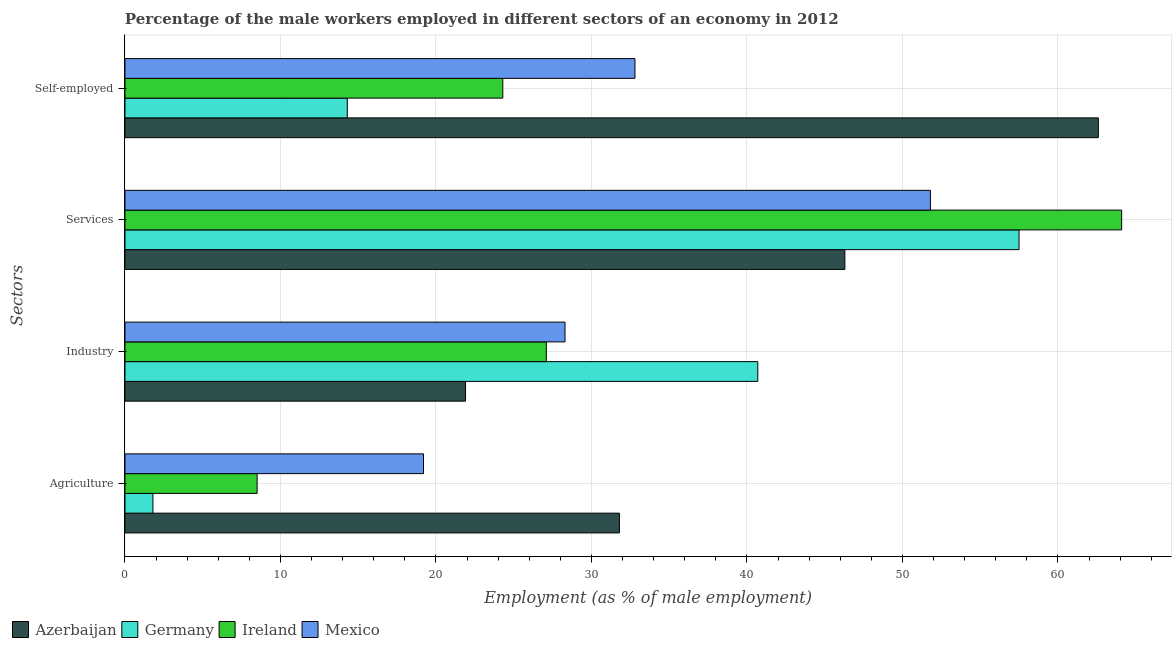How many different coloured bars are there?
Offer a very short reply. 4. How many groups of bars are there?
Give a very brief answer. 4. Are the number of bars on each tick of the Y-axis equal?
Ensure brevity in your answer.  Yes. What is the label of the 4th group of bars from the top?
Your answer should be compact. Agriculture. What is the percentage of male workers in agriculture in Ireland?
Offer a very short reply. 8.5. Across all countries, what is the maximum percentage of self employed male workers?
Provide a short and direct response. 62.6. Across all countries, what is the minimum percentage of male workers in agriculture?
Your response must be concise. 1.8. In which country was the percentage of male workers in industry maximum?
Offer a very short reply. Germany. In which country was the percentage of self employed male workers minimum?
Your response must be concise. Germany. What is the total percentage of male workers in industry in the graph?
Ensure brevity in your answer.  118. What is the difference between the percentage of male workers in agriculture in Ireland and that in Germany?
Your answer should be compact. 6.7. What is the difference between the percentage of male workers in agriculture in Mexico and the percentage of self employed male workers in Ireland?
Keep it short and to the point. -5.1. What is the average percentage of male workers in agriculture per country?
Provide a succinct answer. 15.32. What is the difference between the percentage of male workers in industry and percentage of male workers in services in Ireland?
Offer a very short reply. -37. What is the ratio of the percentage of male workers in agriculture in Mexico to that in Ireland?
Your response must be concise. 2.26. Is the percentage of male workers in services in Ireland less than that in Mexico?
Keep it short and to the point. No. What is the difference between the highest and the second highest percentage of male workers in agriculture?
Give a very brief answer. 12.6. What is the difference between the highest and the lowest percentage of male workers in industry?
Offer a terse response. 18.8. Is the sum of the percentage of male workers in agriculture in Mexico and Germany greater than the maximum percentage of male workers in industry across all countries?
Provide a succinct answer. No. What does the 1st bar from the top in Self-employed represents?
Make the answer very short. Mexico. What does the 2nd bar from the bottom in Industry represents?
Make the answer very short. Germany. What is the difference between two consecutive major ticks on the X-axis?
Offer a terse response. 10. Does the graph contain grids?
Give a very brief answer. Yes. How many legend labels are there?
Your answer should be compact. 4. How are the legend labels stacked?
Give a very brief answer. Horizontal. What is the title of the graph?
Your response must be concise. Percentage of the male workers employed in different sectors of an economy in 2012. What is the label or title of the X-axis?
Offer a terse response. Employment (as % of male employment). What is the label or title of the Y-axis?
Provide a succinct answer. Sectors. What is the Employment (as % of male employment) in Azerbaijan in Agriculture?
Ensure brevity in your answer.  31.8. What is the Employment (as % of male employment) of Germany in Agriculture?
Offer a terse response. 1.8. What is the Employment (as % of male employment) in Ireland in Agriculture?
Your response must be concise. 8.5. What is the Employment (as % of male employment) in Mexico in Agriculture?
Keep it short and to the point. 19.2. What is the Employment (as % of male employment) in Azerbaijan in Industry?
Offer a very short reply. 21.9. What is the Employment (as % of male employment) of Germany in Industry?
Ensure brevity in your answer.  40.7. What is the Employment (as % of male employment) of Ireland in Industry?
Offer a terse response. 27.1. What is the Employment (as % of male employment) in Mexico in Industry?
Your answer should be compact. 28.3. What is the Employment (as % of male employment) in Azerbaijan in Services?
Give a very brief answer. 46.3. What is the Employment (as % of male employment) in Germany in Services?
Provide a short and direct response. 57.5. What is the Employment (as % of male employment) in Ireland in Services?
Offer a very short reply. 64.1. What is the Employment (as % of male employment) in Mexico in Services?
Your response must be concise. 51.8. What is the Employment (as % of male employment) of Azerbaijan in Self-employed?
Make the answer very short. 62.6. What is the Employment (as % of male employment) in Germany in Self-employed?
Your answer should be very brief. 14.3. What is the Employment (as % of male employment) in Ireland in Self-employed?
Keep it short and to the point. 24.3. What is the Employment (as % of male employment) in Mexico in Self-employed?
Make the answer very short. 32.8. Across all Sectors, what is the maximum Employment (as % of male employment) of Azerbaijan?
Keep it short and to the point. 62.6. Across all Sectors, what is the maximum Employment (as % of male employment) in Germany?
Offer a terse response. 57.5. Across all Sectors, what is the maximum Employment (as % of male employment) of Ireland?
Keep it short and to the point. 64.1. Across all Sectors, what is the maximum Employment (as % of male employment) in Mexico?
Your response must be concise. 51.8. Across all Sectors, what is the minimum Employment (as % of male employment) in Azerbaijan?
Your answer should be very brief. 21.9. Across all Sectors, what is the minimum Employment (as % of male employment) of Germany?
Ensure brevity in your answer.  1.8. Across all Sectors, what is the minimum Employment (as % of male employment) of Mexico?
Offer a very short reply. 19.2. What is the total Employment (as % of male employment) of Azerbaijan in the graph?
Provide a short and direct response. 162.6. What is the total Employment (as % of male employment) of Germany in the graph?
Ensure brevity in your answer.  114.3. What is the total Employment (as % of male employment) in Ireland in the graph?
Your answer should be compact. 124. What is the total Employment (as % of male employment) of Mexico in the graph?
Ensure brevity in your answer.  132.1. What is the difference between the Employment (as % of male employment) in Germany in Agriculture and that in Industry?
Provide a short and direct response. -38.9. What is the difference between the Employment (as % of male employment) in Ireland in Agriculture and that in Industry?
Keep it short and to the point. -18.6. What is the difference between the Employment (as % of male employment) in Mexico in Agriculture and that in Industry?
Provide a succinct answer. -9.1. What is the difference between the Employment (as % of male employment) in Azerbaijan in Agriculture and that in Services?
Give a very brief answer. -14.5. What is the difference between the Employment (as % of male employment) in Germany in Agriculture and that in Services?
Make the answer very short. -55.7. What is the difference between the Employment (as % of male employment) of Ireland in Agriculture and that in Services?
Offer a terse response. -55.6. What is the difference between the Employment (as % of male employment) in Mexico in Agriculture and that in Services?
Offer a very short reply. -32.6. What is the difference between the Employment (as % of male employment) in Azerbaijan in Agriculture and that in Self-employed?
Provide a succinct answer. -30.8. What is the difference between the Employment (as % of male employment) of Ireland in Agriculture and that in Self-employed?
Ensure brevity in your answer.  -15.8. What is the difference between the Employment (as % of male employment) of Azerbaijan in Industry and that in Services?
Your answer should be very brief. -24.4. What is the difference between the Employment (as % of male employment) in Germany in Industry and that in Services?
Your answer should be compact. -16.8. What is the difference between the Employment (as % of male employment) in Ireland in Industry and that in Services?
Provide a succinct answer. -37. What is the difference between the Employment (as % of male employment) in Mexico in Industry and that in Services?
Your answer should be compact. -23.5. What is the difference between the Employment (as % of male employment) in Azerbaijan in Industry and that in Self-employed?
Your answer should be compact. -40.7. What is the difference between the Employment (as % of male employment) in Germany in Industry and that in Self-employed?
Keep it short and to the point. 26.4. What is the difference between the Employment (as % of male employment) of Mexico in Industry and that in Self-employed?
Offer a terse response. -4.5. What is the difference between the Employment (as % of male employment) in Azerbaijan in Services and that in Self-employed?
Make the answer very short. -16.3. What is the difference between the Employment (as % of male employment) of Germany in Services and that in Self-employed?
Keep it short and to the point. 43.2. What is the difference between the Employment (as % of male employment) of Ireland in Services and that in Self-employed?
Give a very brief answer. 39.8. What is the difference between the Employment (as % of male employment) in Mexico in Services and that in Self-employed?
Make the answer very short. 19. What is the difference between the Employment (as % of male employment) of Azerbaijan in Agriculture and the Employment (as % of male employment) of Germany in Industry?
Give a very brief answer. -8.9. What is the difference between the Employment (as % of male employment) of Azerbaijan in Agriculture and the Employment (as % of male employment) of Ireland in Industry?
Your answer should be compact. 4.7. What is the difference between the Employment (as % of male employment) in Azerbaijan in Agriculture and the Employment (as % of male employment) in Mexico in Industry?
Offer a very short reply. 3.5. What is the difference between the Employment (as % of male employment) in Germany in Agriculture and the Employment (as % of male employment) in Ireland in Industry?
Ensure brevity in your answer.  -25.3. What is the difference between the Employment (as % of male employment) of Germany in Agriculture and the Employment (as % of male employment) of Mexico in Industry?
Offer a terse response. -26.5. What is the difference between the Employment (as % of male employment) of Ireland in Agriculture and the Employment (as % of male employment) of Mexico in Industry?
Offer a terse response. -19.8. What is the difference between the Employment (as % of male employment) in Azerbaijan in Agriculture and the Employment (as % of male employment) in Germany in Services?
Provide a short and direct response. -25.7. What is the difference between the Employment (as % of male employment) of Azerbaijan in Agriculture and the Employment (as % of male employment) of Ireland in Services?
Provide a short and direct response. -32.3. What is the difference between the Employment (as % of male employment) in Azerbaijan in Agriculture and the Employment (as % of male employment) in Mexico in Services?
Provide a succinct answer. -20. What is the difference between the Employment (as % of male employment) in Germany in Agriculture and the Employment (as % of male employment) in Ireland in Services?
Offer a terse response. -62.3. What is the difference between the Employment (as % of male employment) in Germany in Agriculture and the Employment (as % of male employment) in Mexico in Services?
Your answer should be compact. -50. What is the difference between the Employment (as % of male employment) in Ireland in Agriculture and the Employment (as % of male employment) in Mexico in Services?
Your response must be concise. -43.3. What is the difference between the Employment (as % of male employment) in Azerbaijan in Agriculture and the Employment (as % of male employment) in Germany in Self-employed?
Your response must be concise. 17.5. What is the difference between the Employment (as % of male employment) of Azerbaijan in Agriculture and the Employment (as % of male employment) of Ireland in Self-employed?
Your response must be concise. 7.5. What is the difference between the Employment (as % of male employment) in Germany in Agriculture and the Employment (as % of male employment) in Ireland in Self-employed?
Provide a short and direct response. -22.5. What is the difference between the Employment (as % of male employment) of Germany in Agriculture and the Employment (as % of male employment) of Mexico in Self-employed?
Your answer should be compact. -31. What is the difference between the Employment (as % of male employment) of Ireland in Agriculture and the Employment (as % of male employment) of Mexico in Self-employed?
Make the answer very short. -24.3. What is the difference between the Employment (as % of male employment) in Azerbaijan in Industry and the Employment (as % of male employment) in Germany in Services?
Your answer should be very brief. -35.6. What is the difference between the Employment (as % of male employment) of Azerbaijan in Industry and the Employment (as % of male employment) of Ireland in Services?
Ensure brevity in your answer.  -42.2. What is the difference between the Employment (as % of male employment) in Azerbaijan in Industry and the Employment (as % of male employment) in Mexico in Services?
Offer a terse response. -29.9. What is the difference between the Employment (as % of male employment) in Germany in Industry and the Employment (as % of male employment) in Ireland in Services?
Your answer should be very brief. -23.4. What is the difference between the Employment (as % of male employment) of Ireland in Industry and the Employment (as % of male employment) of Mexico in Services?
Your response must be concise. -24.7. What is the difference between the Employment (as % of male employment) of Azerbaijan in Industry and the Employment (as % of male employment) of Mexico in Self-employed?
Your response must be concise. -10.9. What is the difference between the Employment (as % of male employment) in Germany in Industry and the Employment (as % of male employment) in Ireland in Self-employed?
Your response must be concise. 16.4. What is the difference between the Employment (as % of male employment) in Ireland in Industry and the Employment (as % of male employment) in Mexico in Self-employed?
Ensure brevity in your answer.  -5.7. What is the difference between the Employment (as % of male employment) of Azerbaijan in Services and the Employment (as % of male employment) of Ireland in Self-employed?
Provide a short and direct response. 22. What is the difference between the Employment (as % of male employment) in Germany in Services and the Employment (as % of male employment) in Ireland in Self-employed?
Give a very brief answer. 33.2. What is the difference between the Employment (as % of male employment) of Germany in Services and the Employment (as % of male employment) of Mexico in Self-employed?
Make the answer very short. 24.7. What is the difference between the Employment (as % of male employment) in Ireland in Services and the Employment (as % of male employment) in Mexico in Self-employed?
Provide a succinct answer. 31.3. What is the average Employment (as % of male employment) of Azerbaijan per Sectors?
Your response must be concise. 40.65. What is the average Employment (as % of male employment) in Germany per Sectors?
Give a very brief answer. 28.57. What is the average Employment (as % of male employment) of Mexico per Sectors?
Make the answer very short. 33.02. What is the difference between the Employment (as % of male employment) of Azerbaijan and Employment (as % of male employment) of Germany in Agriculture?
Ensure brevity in your answer.  30. What is the difference between the Employment (as % of male employment) of Azerbaijan and Employment (as % of male employment) of Ireland in Agriculture?
Offer a very short reply. 23.3. What is the difference between the Employment (as % of male employment) of Azerbaijan and Employment (as % of male employment) of Mexico in Agriculture?
Provide a short and direct response. 12.6. What is the difference between the Employment (as % of male employment) in Germany and Employment (as % of male employment) in Ireland in Agriculture?
Make the answer very short. -6.7. What is the difference between the Employment (as % of male employment) of Germany and Employment (as % of male employment) of Mexico in Agriculture?
Your answer should be very brief. -17.4. What is the difference between the Employment (as % of male employment) in Ireland and Employment (as % of male employment) in Mexico in Agriculture?
Keep it short and to the point. -10.7. What is the difference between the Employment (as % of male employment) of Azerbaijan and Employment (as % of male employment) of Germany in Industry?
Offer a terse response. -18.8. What is the difference between the Employment (as % of male employment) in Azerbaijan and Employment (as % of male employment) in Ireland in Industry?
Provide a succinct answer. -5.2. What is the difference between the Employment (as % of male employment) of Germany and Employment (as % of male employment) of Mexico in Industry?
Offer a very short reply. 12.4. What is the difference between the Employment (as % of male employment) of Azerbaijan and Employment (as % of male employment) of Germany in Services?
Offer a very short reply. -11.2. What is the difference between the Employment (as % of male employment) in Azerbaijan and Employment (as % of male employment) in Ireland in Services?
Give a very brief answer. -17.8. What is the difference between the Employment (as % of male employment) in Azerbaijan and Employment (as % of male employment) in Mexico in Services?
Offer a terse response. -5.5. What is the difference between the Employment (as % of male employment) of Germany and Employment (as % of male employment) of Mexico in Services?
Your answer should be compact. 5.7. What is the difference between the Employment (as % of male employment) in Ireland and Employment (as % of male employment) in Mexico in Services?
Provide a short and direct response. 12.3. What is the difference between the Employment (as % of male employment) in Azerbaijan and Employment (as % of male employment) in Germany in Self-employed?
Your answer should be very brief. 48.3. What is the difference between the Employment (as % of male employment) in Azerbaijan and Employment (as % of male employment) in Ireland in Self-employed?
Keep it short and to the point. 38.3. What is the difference between the Employment (as % of male employment) of Azerbaijan and Employment (as % of male employment) of Mexico in Self-employed?
Provide a succinct answer. 29.8. What is the difference between the Employment (as % of male employment) of Germany and Employment (as % of male employment) of Mexico in Self-employed?
Your answer should be very brief. -18.5. What is the difference between the Employment (as % of male employment) in Ireland and Employment (as % of male employment) in Mexico in Self-employed?
Make the answer very short. -8.5. What is the ratio of the Employment (as % of male employment) in Azerbaijan in Agriculture to that in Industry?
Your answer should be compact. 1.45. What is the ratio of the Employment (as % of male employment) of Germany in Agriculture to that in Industry?
Your answer should be very brief. 0.04. What is the ratio of the Employment (as % of male employment) in Ireland in Agriculture to that in Industry?
Give a very brief answer. 0.31. What is the ratio of the Employment (as % of male employment) of Mexico in Agriculture to that in Industry?
Offer a terse response. 0.68. What is the ratio of the Employment (as % of male employment) of Azerbaijan in Agriculture to that in Services?
Provide a succinct answer. 0.69. What is the ratio of the Employment (as % of male employment) in Germany in Agriculture to that in Services?
Offer a terse response. 0.03. What is the ratio of the Employment (as % of male employment) in Ireland in Agriculture to that in Services?
Ensure brevity in your answer.  0.13. What is the ratio of the Employment (as % of male employment) in Mexico in Agriculture to that in Services?
Your answer should be very brief. 0.37. What is the ratio of the Employment (as % of male employment) in Azerbaijan in Agriculture to that in Self-employed?
Provide a short and direct response. 0.51. What is the ratio of the Employment (as % of male employment) in Germany in Agriculture to that in Self-employed?
Your response must be concise. 0.13. What is the ratio of the Employment (as % of male employment) in Ireland in Agriculture to that in Self-employed?
Provide a short and direct response. 0.35. What is the ratio of the Employment (as % of male employment) in Mexico in Agriculture to that in Self-employed?
Offer a terse response. 0.59. What is the ratio of the Employment (as % of male employment) of Azerbaijan in Industry to that in Services?
Offer a very short reply. 0.47. What is the ratio of the Employment (as % of male employment) in Germany in Industry to that in Services?
Provide a short and direct response. 0.71. What is the ratio of the Employment (as % of male employment) in Ireland in Industry to that in Services?
Keep it short and to the point. 0.42. What is the ratio of the Employment (as % of male employment) of Mexico in Industry to that in Services?
Make the answer very short. 0.55. What is the ratio of the Employment (as % of male employment) of Azerbaijan in Industry to that in Self-employed?
Make the answer very short. 0.35. What is the ratio of the Employment (as % of male employment) in Germany in Industry to that in Self-employed?
Your answer should be very brief. 2.85. What is the ratio of the Employment (as % of male employment) of Ireland in Industry to that in Self-employed?
Provide a short and direct response. 1.12. What is the ratio of the Employment (as % of male employment) of Mexico in Industry to that in Self-employed?
Provide a succinct answer. 0.86. What is the ratio of the Employment (as % of male employment) in Azerbaijan in Services to that in Self-employed?
Offer a terse response. 0.74. What is the ratio of the Employment (as % of male employment) in Germany in Services to that in Self-employed?
Provide a succinct answer. 4.02. What is the ratio of the Employment (as % of male employment) of Ireland in Services to that in Self-employed?
Your answer should be compact. 2.64. What is the ratio of the Employment (as % of male employment) in Mexico in Services to that in Self-employed?
Provide a succinct answer. 1.58. What is the difference between the highest and the second highest Employment (as % of male employment) in Ireland?
Provide a short and direct response. 37. What is the difference between the highest and the second highest Employment (as % of male employment) of Mexico?
Give a very brief answer. 19. What is the difference between the highest and the lowest Employment (as % of male employment) in Azerbaijan?
Provide a succinct answer. 40.7. What is the difference between the highest and the lowest Employment (as % of male employment) in Germany?
Offer a very short reply. 55.7. What is the difference between the highest and the lowest Employment (as % of male employment) of Ireland?
Keep it short and to the point. 55.6. What is the difference between the highest and the lowest Employment (as % of male employment) in Mexico?
Your response must be concise. 32.6. 